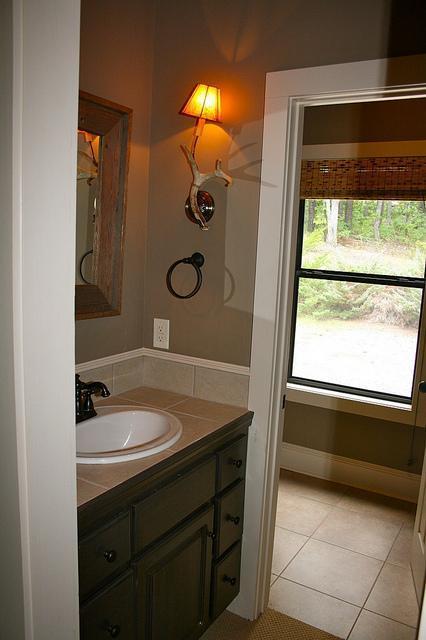How many sinks are there?
Give a very brief answer. 1. 